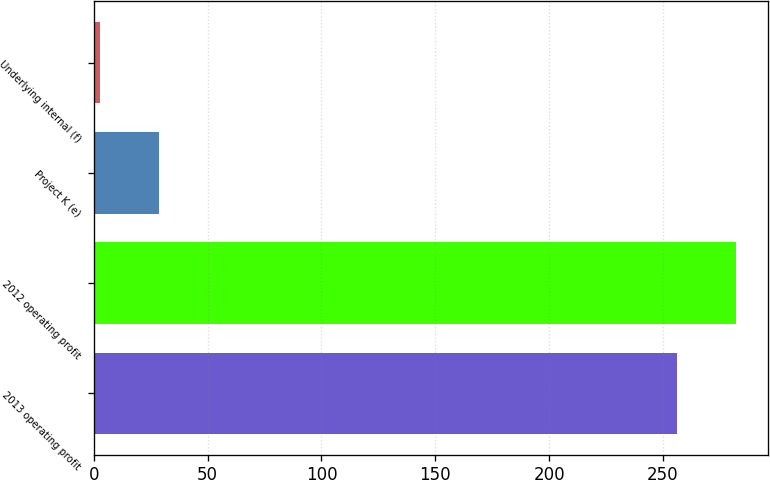Convert chart. <chart><loc_0><loc_0><loc_500><loc_500><bar_chart><fcel>2013 operating profit<fcel>2012 operating profit<fcel>Project K (e)<fcel>Underlying internal (f)<nl><fcel>256<fcel>281.84<fcel>28.44<fcel>2.6<nl></chart> 